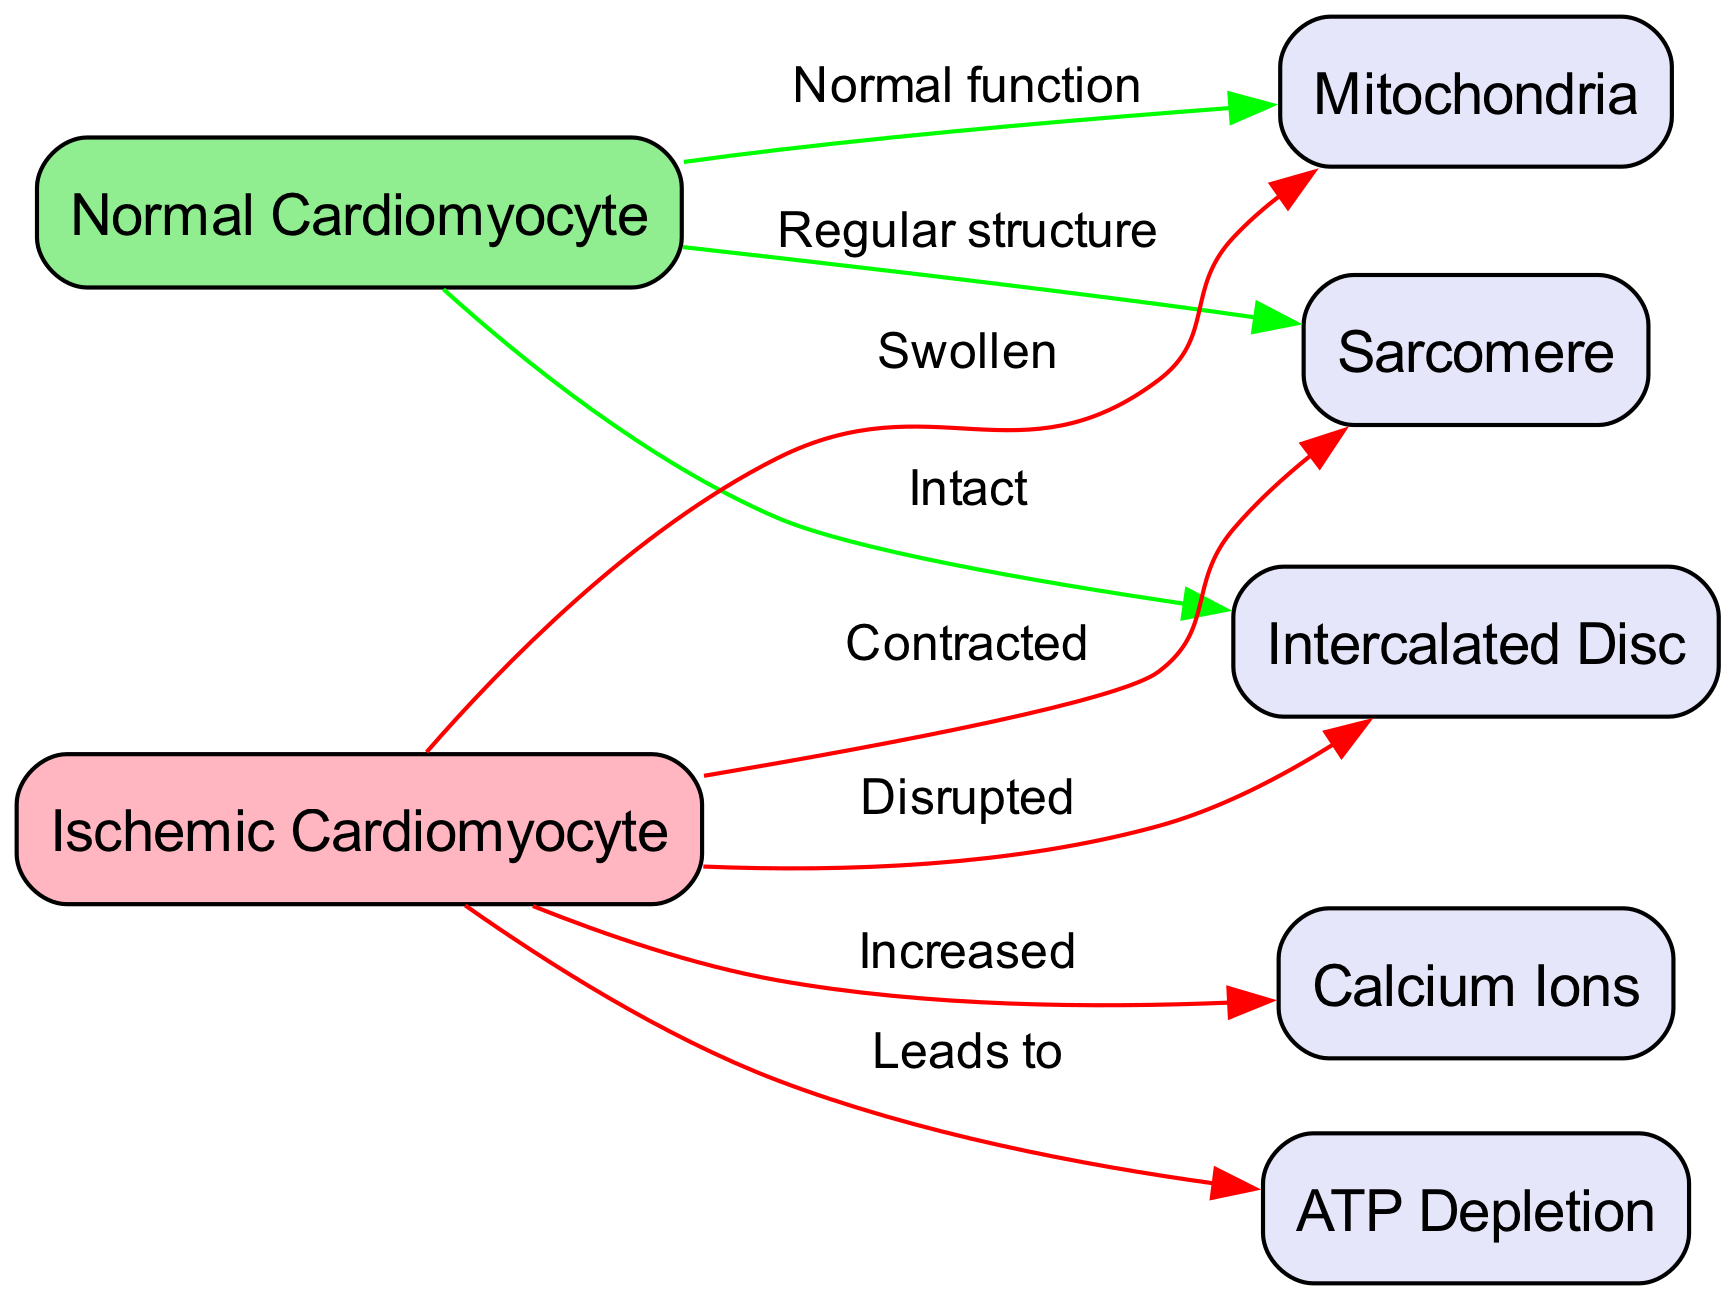What is the total number of nodes in the diagram? The diagram lists several nodes: "Normal Cardiomyocyte," "Ischemic Cardiomyocyte," "Mitochondria," "Sarcomere," "Intercalated Disc," "Calcium Ions," and "ATP Depletion." Counting each of these gives a total of seven nodes.
Answer: 7 How many edges originate from the ischemic cardiomyocyte? Examining the connections, the "Ischemic Cardiomyocyte" node has four outgoing edges: to "Mitochondria," "Sarcomere," "Intercalated Disc," and "Calcium Ions." This indicates that four edges originate from this node.
Answer: 4 What color represents a normal cardiomyocyte in the diagram? The "Normal Cardiomyocyte" is depicted in light green, which is specified in the code that assigns colors to nodes based on their status.
Answer: Light green Describe the effect of ischemia on mitochondria. The edge from "Ischemic Cardiomyocyte" to "Mitochondria" is labeled "Swollen," indicating that ischemia leads to a swelling of the mitochondria. The word "swollen" clearly defines the condition of the mitochondria in an ischemic state.
Answer: Swollen What structural change occurs to the sarcomere in ischemia? The edge from "Ischemic Cardiomyocyte" to "Sarcomere" is labeled "Contracted," which shows that the sarcomere structure becomes contracted during ischemic conditions. This contraction status highlights the effects of ischemia on cellular structure.
Answer: Contracted What relationship exists between ischemic cardiomyocyte and calcium ions? The relationship between the "Ischemic Cardiomyocyte" and "Calcium Ions" is shown by an edge labeled "Increased," suggesting that ischemic conditions lead to an increase in calcium ions within the cardiomyocyte.
Answer: Increased What impact does ATP depletion have in ischemic cardiomyocytes? The edge labeled "Leads to" connects "Ischemic Cardiomyocyte" to "ATP Depletion," indicating that ischemia results in ATP depletion within the cardiomyocyte, depicting a critical consequence of ischemia.
Answer: ATP Depletion How is the intercalated disc affected in ischemic conditions? The edge from "Ischemic Cardiomyocyte" to "Intercalated Disc" is labeled "Disrupted," signifying a structural disruption of the intercalated discs when ischemia occurs in the myocardium.
Answer: Disrupted 